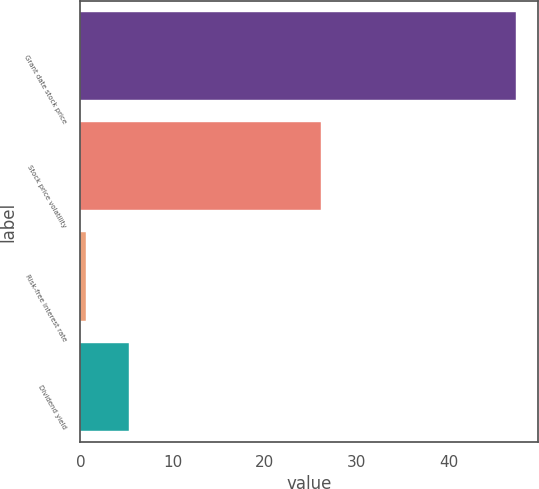Convert chart to OTSL. <chart><loc_0><loc_0><loc_500><loc_500><bar_chart><fcel>Grant date stock price<fcel>Stock price volatility<fcel>Risk-free interest rate<fcel>Dividend yield<nl><fcel>47.28<fcel>26.12<fcel>0.65<fcel>5.31<nl></chart> 